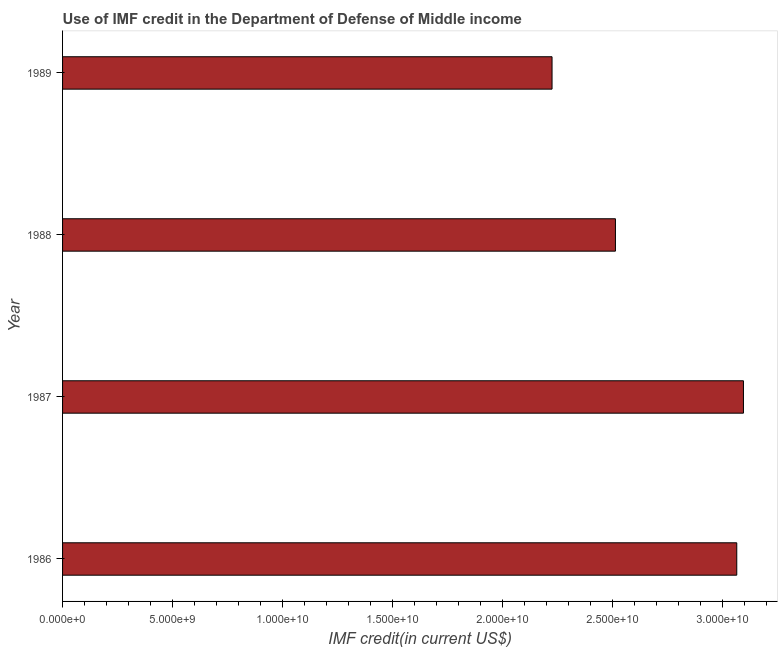Does the graph contain grids?
Ensure brevity in your answer.  No. What is the title of the graph?
Provide a short and direct response. Use of IMF credit in the Department of Defense of Middle income. What is the label or title of the X-axis?
Provide a short and direct response. IMF credit(in current US$). What is the use of imf credit in dod in 1988?
Keep it short and to the point. 2.51e+1. Across all years, what is the maximum use of imf credit in dod?
Provide a succinct answer. 3.09e+1. Across all years, what is the minimum use of imf credit in dod?
Offer a very short reply. 2.22e+1. In which year was the use of imf credit in dod minimum?
Provide a short and direct response. 1989. What is the sum of the use of imf credit in dod?
Offer a terse response. 1.09e+11. What is the difference between the use of imf credit in dod in 1987 and 1989?
Offer a very short reply. 8.70e+09. What is the average use of imf credit in dod per year?
Provide a succinct answer. 2.72e+1. What is the median use of imf credit in dod?
Give a very brief answer. 2.79e+1. Do a majority of the years between 1988 and 1989 (inclusive) have use of imf credit in dod greater than 12000000000 US$?
Provide a succinct answer. Yes. What is the ratio of the use of imf credit in dod in 1986 to that in 1988?
Provide a succinct answer. 1.22. Is the use of imf credit in dod in 1986 less than that in 1989?
Give a very brief answer. No. What is the difference between the highest and the second highest use of imf credit in dod?
Keep it short and to the point. 3.04e+08. Is the sum of the use of imf credit in dod in 1987 and 1988 greater than the maximum use of imf credit in dod across all years?
Make the answer very short. Yes. What is the difference between the highest and the lowest use of imf credit in dod?
Keep it short and to the point. 8.70e+09. In how many years, is the use of imf credit in dod greater than the average use of imf credit in dod taken over all years?
Give a very brief answer. 2. How many years are there in the graph?
Make the answer very short. 4. What is the IMF credit(in current US$) of 1986?
Provide a succinct answer. 3.06e+1. What is the IMF credit(in current US$) of 1987?
Offer a very short reply. 3.09e+1. What is the IMF credit(in current US$) in 1988?
Your answer should be compact. 2.51e+1. What is the IMF credit(in current US$) of 1989?
Provide a succinct answer. 2.22e+1. What is the difference between the IMF credit(in current US$) in 1986 and 1987?
Provide a short and direct response. -3.04e+08. What is the difference between the IMF credit(in current US$) in 1986 and 1988?
Your answer should be very brief. 5.52e+09. What is the difference between the IMF credit(in current US$) in 1986 and 1989?
Make the answer very short. 8.40e+09. What is the difference between the IMF credit(in current US$) in 1987 and 1988?
Make the answer very short. 5.82e+09. What is the difference between the IMF credit(in current US$) in 1987 and 1989?
Offer a very short reply. 8.70e+09. What is the difference between the IMF credit(in current US$) in 1988 and 1989?
Your answer should be compact. 2.88e+09. What is the ratio of the IMF credit(in current US$) in 1986 to that in 1988?
Provide a short and direct response. 1.22. What is the ratio of the IMF credit(in current US$) in 1986 to that in 1989?
Offer a very short reply. 1.38. What is the ratio of the IMF credit(in current US$) in 1987 to that in 1988?
Your answer should be very brief. 1.23. What is the ratio of the IMF credit(in current US$) in 1987 to that in 1989?
Make the answer very short. 1.39. What is the ratio of the IMF credit(in current US$) in 1988 to that in 1989?
Make the answer very short. 1.13. 